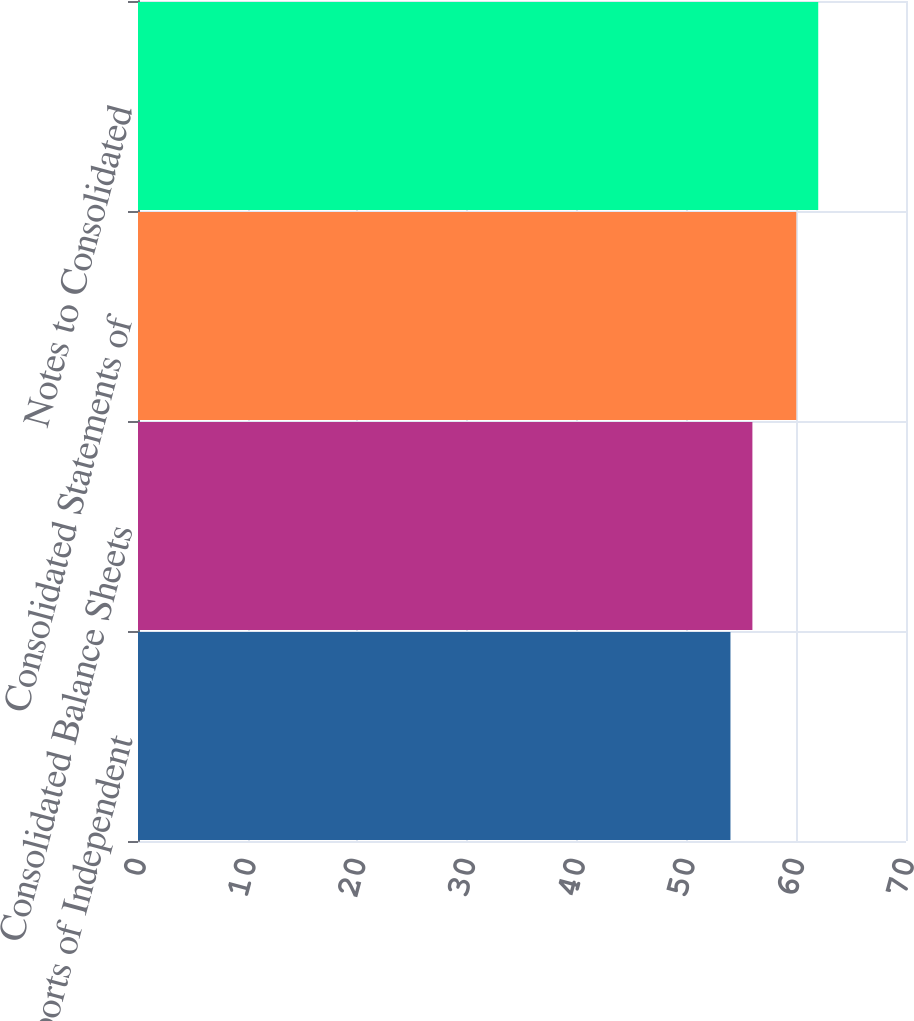Convert chart. <chart><loc_0><loc_0><loc_500><loc_500><bar_chart><fcel>Reports of Independent<fcel>Consolidated Balance Sheets<fcel>Consolidated Statements of<fcel>Notes to Consolidated<nl><fcel>54<fcel>56<fcel>60<fcel>62<nl></chart> 